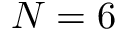Convert formula to latex. <formula><loc_0><loc_0><loc_500><loc_500>N = 6</formula> 